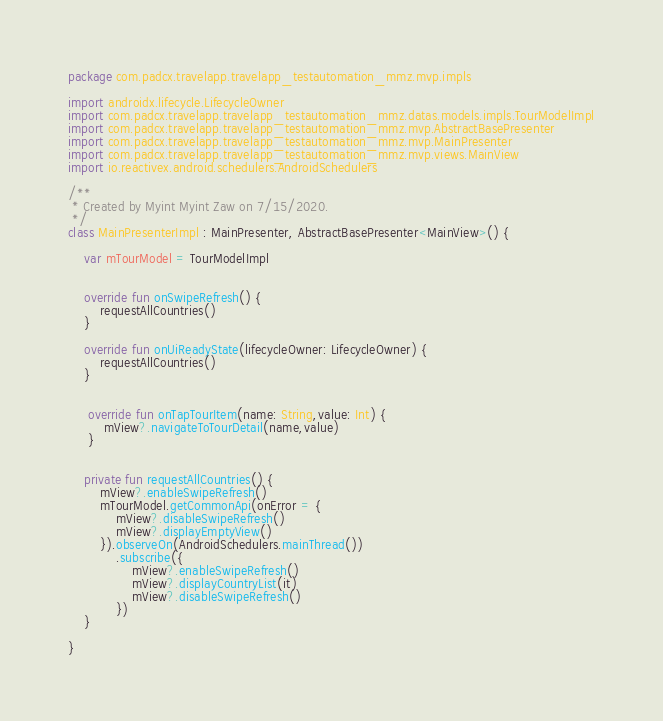Convert code to text. <code><loc_0><loc_0><loc_500><loc_500><_Kotlin_>package com.padcx.travelapp.travelapp_testautomation_mmz.mvp.impls

import androidx.lifecycle.LifecycleOwner
import com.padcx.travelapp.travelapp_testautomation_mmz.datas.models.impls.TourModelImpl
import com.padcx.travelapp.travelapp_testautomation_mmz.mvp.AbstractBasePresenter
import com.padcx.travelapp.travelapp_testautomation_mmz.mvp.MainPresenter
import com.padcx.travelapp.travelapp_testautomation_mmz.mvp.views.MainView
import io.reactivex.android.schedulers.AndroidSchedulers

/**
 * Created by Myint Myint Zaw on 7/15/2020.
 */
class MainPresenterImpl : MainPresenter, AbstractBasePresenter<MainView>() {

    var mTourModel = TourModelImpl


    override fun onSwipeRefresh() {
        requestAllCountries()
    }

    override fun onUiReadyState(lifecycleOwner: LifecycleOwner) {
        requestAllCountries()
    }


     override fun onTapTourItem(name: String,value: Int) {
         mView?.navigateToTourDetail(name,value)
     }


    private fun requestAllCountries() {
        mView?.enableSwipeRefresh()
        mTourModel.getCommonApi(onError = {
            mView?.disableSwipeRefresh()
            mView?.displayEmptyView()
        }).observeOn(AndroidSchedulers.mainThread())
            .subscribe({
                mView?.enableSwipeRefresh()
                mView?.displayCountryList(it)
                mView?.disableSwipeRefresh()
            })
    }

}</code> 